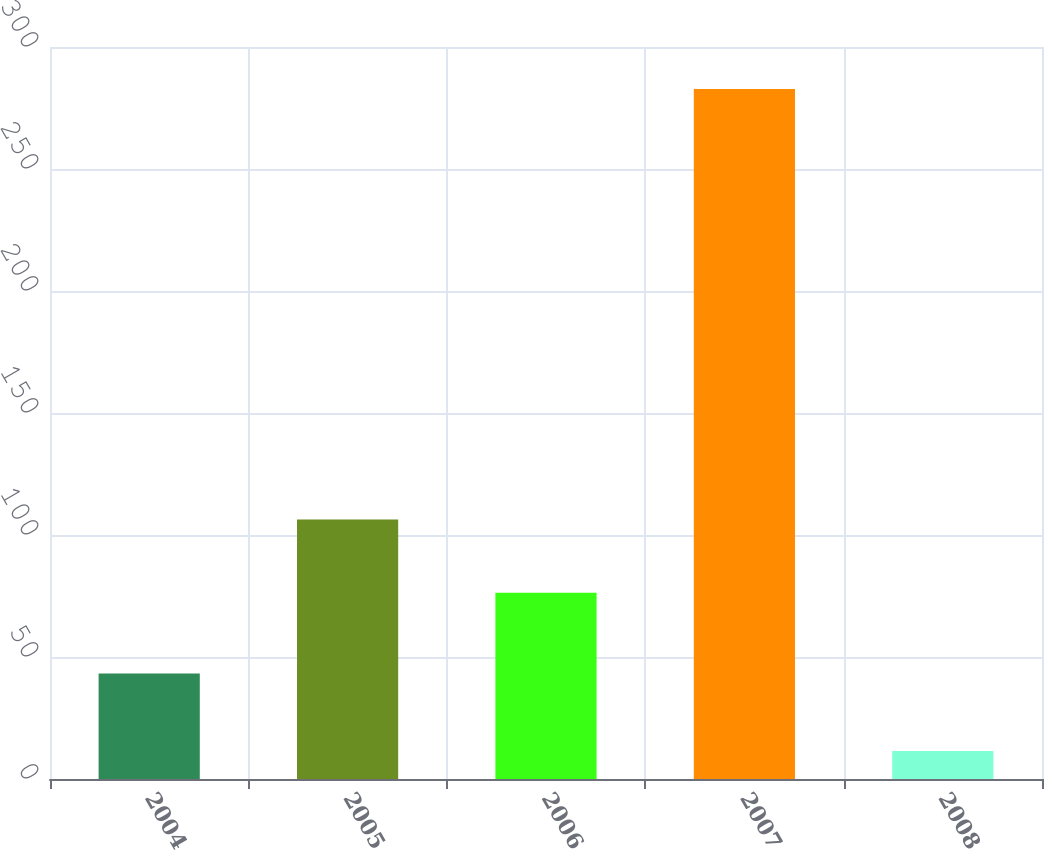<chart> <loc_0><loc_0><loc_500><loc_500><bar_chart><fcel>2004<fcel>2005<fcel>2006<fcel>2007<fcel>2008<nl><fcel>43.2<fcel>106.4<fcel>76.3<fcel>282.8<fcel>11.5<nl></chart> 